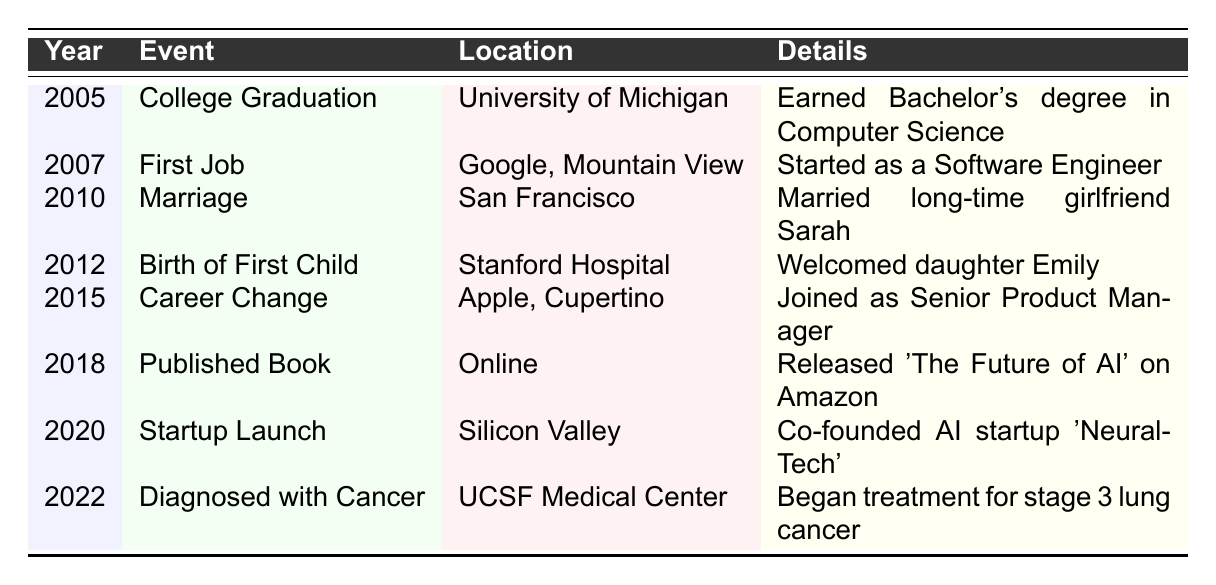What year did John graduate from college? The table indicates that John graduated from college in 2005, as this event is listed with that year.
Answer: 2005 Where did John work when he started his first job? According to the table, John's first job was at Google, located in Mountain View.
Answer: Google, Mountain View How many children did John have by 2012? The table shows that John welcomed his first child, a daughter named Emily, in 2012. As it is the only child mentioned, the answer is one.
Answer: One Was John diagnosed with cancer before or after launching his startup? The table states John launched his startup in 2020 and was diagnosed with cancer in 2022. Therefore, he was diagnosed after the startup launch.
Answer: After What significant life event occurred in 2010? The table reveals that the significant life event in 2010 was John's marriage to his long-time girlfriend Sarah.
Answer: Marriage How many years passed between John's first job and his career change? John's first job was in 2007, and he changed his career in 2015. The difference is 2015 minus 2007, which equals 8 years.
Answer: 8 years Did John publish a book before or after becoming a Senior Product Manager? The table indicates John published a book in 2018 after he became a Senior Product Manager in 2015.
Answer: After What were the two different locations mentioned for John's life events? The table highlights various locations, but two significant ones are the University of Michigan (for graduation) and UCSF Medical Center (for his cancer diagnosis).
Answer: University of Michigan, UCSF Medical Center What is the total number of major life events listed in the table? The table contains 8 entries of major life events. Therefore, the total is simply the count of these entries.
Answer: 8 Which year did John co-found his startup? According to the table, John co-founded his startup in 2020, as noted in the respective row.
Answer: 2020 